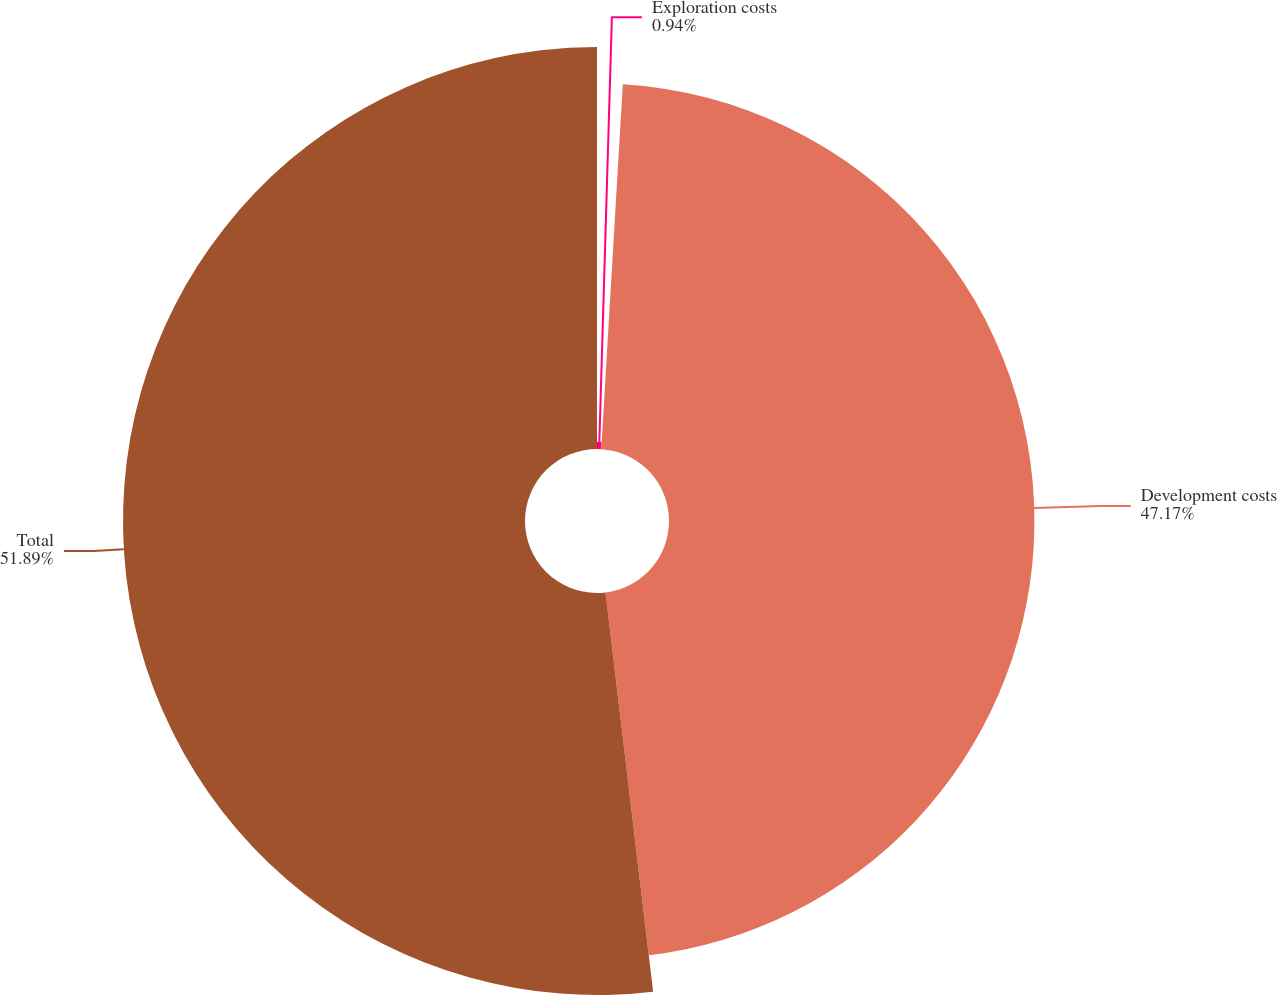Convert chart to OTSL. <chart><loc_0><loc_0><loc_500><loc_500><pie_chart><fcel>Exploration costs<fcel>Development costs<fcel>Total<nl><fcel>0.94%<fcel>47.17%<fcel>51.89%<nl></chart> 